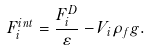<formula> <loc_0><loc_0><loc_500><loc_500>F _ { i } ^ { i n t } = \frac { F _ { i } ^ { D } } { \varepsilon } - V _ { i } \rho _ { f } g .</formula> 